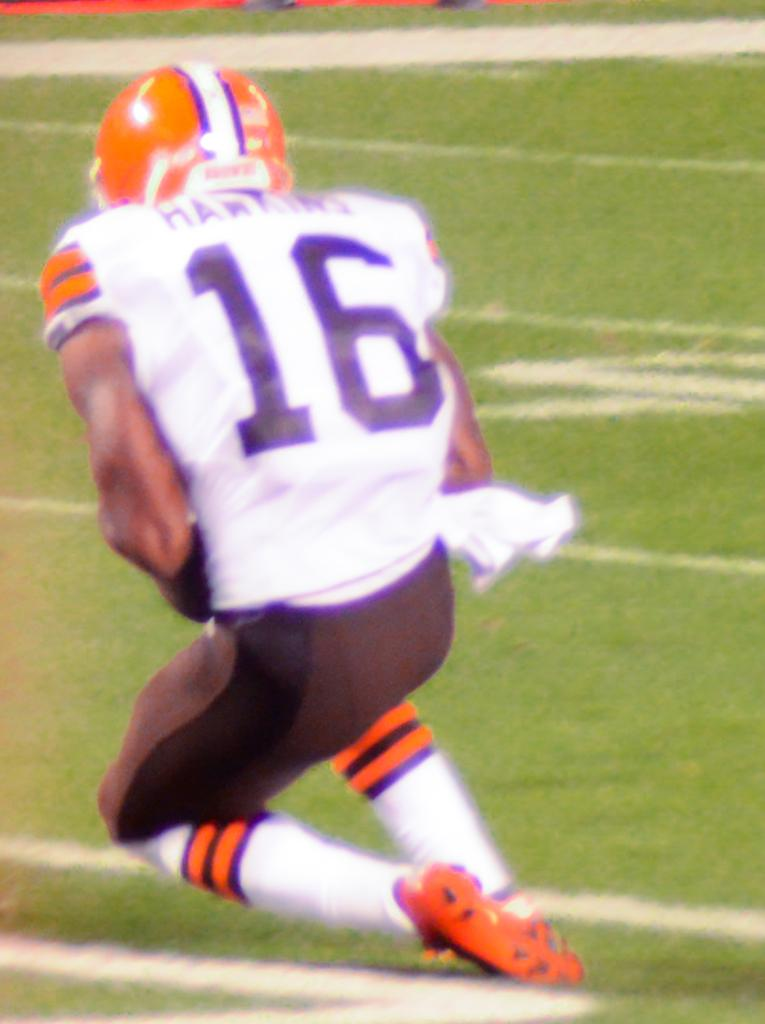What is present in the image? There is a person in the image. Can you describe the person's attire? The person is wearing a dress with white, black, and orange colors. What can be seen beneath the person in the image? The ground is visible in the image. What colors are present on the ground? The ground has green and white colors. What invention is the person holding in the image? There is no invention visible in the image; the person is simply standing on the ground. Is the person resting in the image? The image does not provide any information about the person's state of rest or activity. 